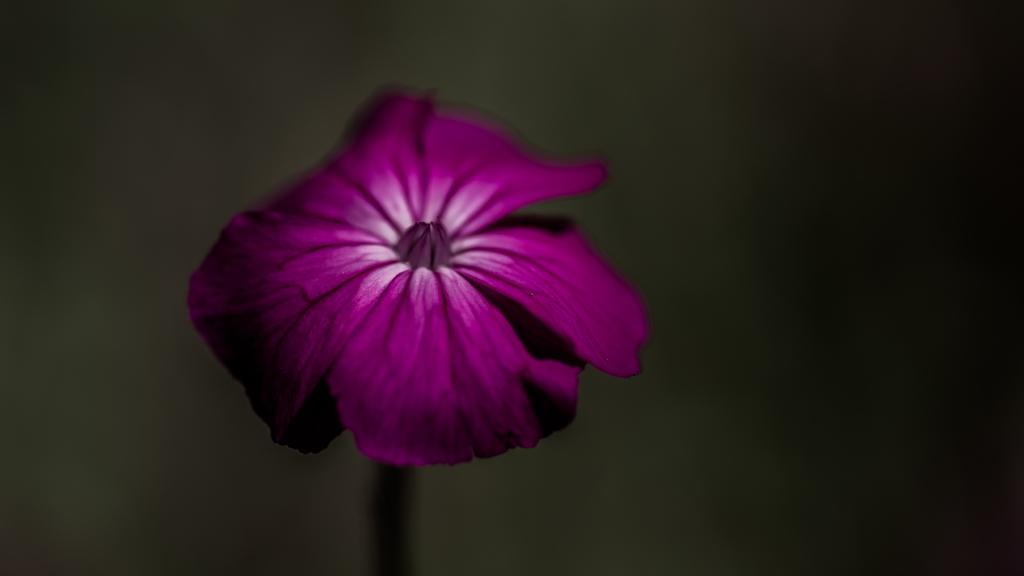What is the main subject of the image? There is a flower in the image. What type of glue is used to attach the circle to the back of the flower in the image? There is no glue or circle present in the image; it only features a flower. 